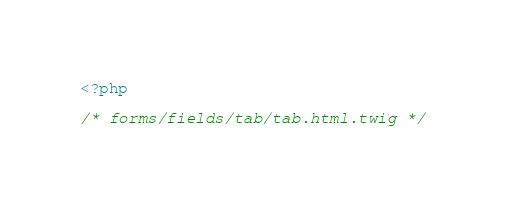Convert code to text. <code><loc_0><loc_0><loc_500><loc_500><_PHP_><?php

/* forms/fields/tab/tab.html.twig */</code> 